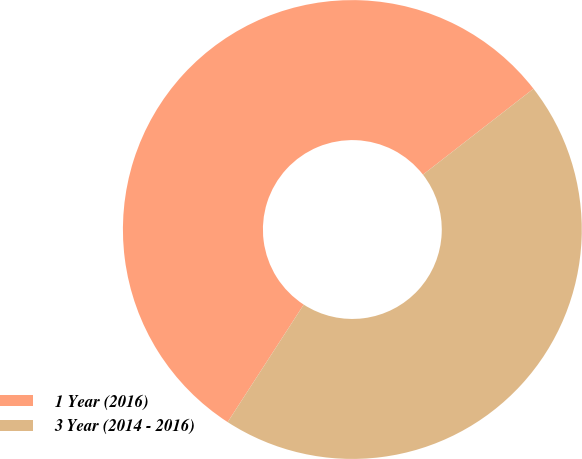Convert chart. <chart><loc_0><loc_0><loc_500><loc_500><pie_chart><fcel>1 Year (2016)<fcel>3 Year (2014 - 2016)<nl><fcel>55.34%<fcel>44.66%<nl></chart> 